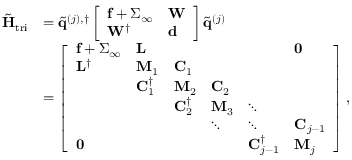Convert formula to latex. <formula><loc_0><loc_0><loc_500><loc_500>\begin{array} { r l } { \tilde { H } _ { t r i } } & { = \tilde { q } ^ { ( j ) , \dagger } \left [ \begin{array} { l l } { f + \Sigma _ { \infty } } & { W } \\ { W ^ { \dagger } } & { d } \end{array} \right ] \tilde { q } ^ { ( j ) } } \\ & { = \left [ \begin{array} { l l l l l l } { f + \Sigma _ { \infty } } & { L } & & & & { 0 } \\ { L ^ { \dagger } } & { M _ { 1 } } & { C _ { 1 } } & & & \\ & { C _ { 1 } ^ { \dagger } } & { M _ { 2 } } & { C _ { 2 } } & & \\ & & { C _ { 2 } ^ { \dagger } } & { M _ { 3 } } & { \ddots } & \\ & & & { \ddots } & { \ddots } & { C _ { j - 1 } } \\ { 0 } & & & & { C _ { j - 1 } ^ { \dagger } } & { M _ { j } } \end{array} \right ] , } \end{array}</formula> 